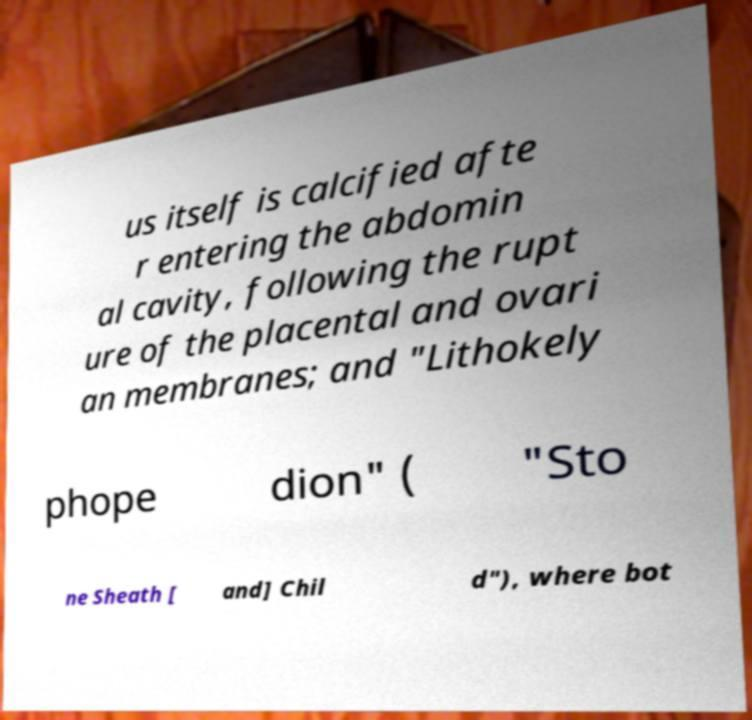Can you read and provide the text displayed in the image?This photo seems to have some interesting text. Can you extract and type it out for me? us itself is calcified afte r entering the abdomin al cavity, following the rupt ure of the placental and ovari an membranes; and "Lithokely phope dion" ( "Sto ne Sheath [ and] Chil d"), where bot 